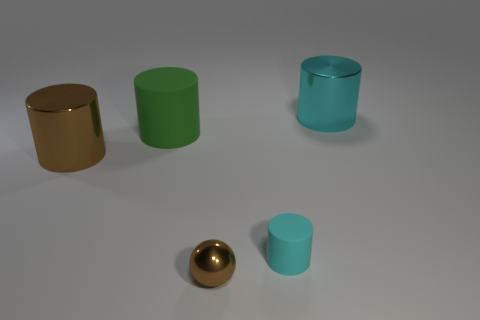Subtract all brown cylinders. Subtract all cyan spheres. How many cylinders are left? 3 Add 2 tiny matte objects. How many objects exist? 7 Subtract all cylinders. How many objects are left? 1 Subtract all green matte cylinders. Subtract all large cyan shiny cylinders. How many objects are left? 3 Add 5 small brown spheres. How many small brown spheres are left? 6 Add 1 big yellow matte things. How many big yellow matte things exist? 1 Subtract 0 brown cubes. How many objects are left? 5 